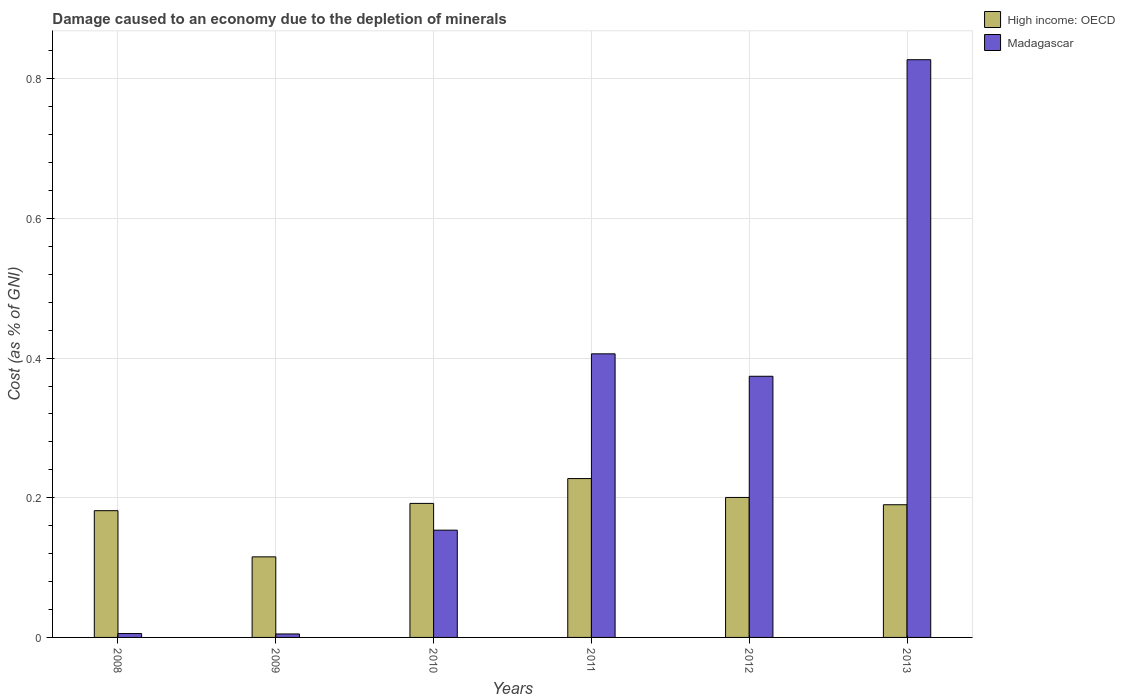How many groups of bars are there?
Your answer should be very brief. 6. Are the number of bars per tick equal to the number of legend labels?
Provide a short and direct response. Yes. How many bars are there on the 1st tick from the left?
Your answer should be compact. 2. How many bars are there on the 1st tick from the right?
Provide a short and direct response. 2. In how many cases, is the number of bars for a given year not equal to the number of legend labels?
Offer a very short reply. 0. What is the cost of damage caused due to the depletion of minerals in High income: OECD in 2011?
Your answer should be compact. 0.23. Across all years, what is the maximum cost of damage caused due to the depletion of minerals in Madagascar?
Make the answer very short. 0.83. Across all years, what is the minimum cost of damage caused due to the depletion of minerals in Madagascar?
Provide a succinct answer. 0. In which year was the cost of damage caused due to the depletion of minerals in High income: OECD minimum?
Your response must be concise. 2009. What is the total cost of damage caused due to the depletion of minerals in High income: OECD in the graph?
Offer a very short reply. 1.11. What is the difference between the cost of damage caused due to the depletion of minerals in High income: OECD in 2009 and that in 2011?
Your response must be concise. -0.11. What is the difference between the cost of damage caused due to the depletion of minerals in Madagascar in 2011 and the cost of damage caused due to the depletion of minerals in High income: OECD in 2009?
Ensure brevity in your answer.  0.29. What is the average cost of damage caused due to the depletion of minerals in High income: OECD per year?
Your answer should be compact. 0.18. In the year 2012, what is the difference between the cost of damage caused due to the depletion of minerals in High income: OECD and cost of damage caused due to the depletion of minerals in Madagascar?
Provide a short and direct response. -0.17. What is the ratio of the cost of damage caused due to the depletion of minerals in Madagascar in 2010 to that in 2011?
Your answer should be very brief. 0.38. Is the cost of damage caused due to the depletion of minerals in High income: OECD in 2009 less than that in 2011?
Offer a terse response. Yes. What is the difference between the highest and the second highest cost of damage caused due to the depletion of minerals in High income: OECD?
Provide a succinct answer. 0.03. What is the difference between the highest and the lowest cost of damage caused due to the depletion of minerals in Madagascar?
Offer a very short reply. 0.82. In how many years, is the cost of damage caused due to the depletion of minerals in Madagascar greater than the average cost of damage caused due to the depletion of minerals in Madagascar taken over all years?
Ensure brevity in your answer.  3. Is the sum of the cost of damage caused due to the depletion of minerals in Madagascar in 2009 and 2013 greater than the maximum cost of damage caused due to the depletion of minerals in High income: OECD across all years?
Make the answer very short. Yes. What does the 2nd bar from the left in 2011 represents?
Keep it short and to the point. Madagascar. What does the 1st bar from the right in 2013 represents?
Provide a succinct answer. Madagascar. How many bars are there?
Your answer should be compact. 12. Are all the bars in the graph horizontal?
Keep it short and to the point. No. How many years are there in the graph?
Offer a very short reply. 6. Are the values on the major ticks of Y-axis written in scientific E-notation?
Make the answer very short. No. Does the graph contain grids?
Provide a short and direct response. Yes. How are the legend labels stacked?
Your answer should be compact. Vertical. What is the title of the graph?
Ensure brevity in your answer.  Damage caused to an economy due to the depletion of minerals. What is the label or title of the X-axis?
Ensure brevity in your answer.  Years. What is the label or title of the Y-axis?
Your answer should be very brief. Cost (as % of GNI). What is the Cost (as % of GNI) in High income: OECD in 2008?
Your response must be concise. 0.18. What is the Cost (as % of GNI) of Madagascar in 2008?
Give a very brief answer. 0.01. What is the Cost (as % of GNI) in High income: OECD in 2009?
Keep it short and to the point. 0.12. What is the Cost (as % of GNI) in Madagascar in 2009?
Give a very brief answer. 0. What is the Cost (as % of GNI) of High income: OECD in 2010?
Provide a short and direct response. 0.19. What is the Cost (as % of GNI) in Madagascar in 2010?
Give a very brief answer. 0.15. What is the Cost (as % of GNI) in High income: OECD in 2011?
Offer a very short reply. 0.23. What is the Cost (as % of GNI) of Madagascar in 2011?
Your answer should be compact. 0.41. What is the Cost (as % of GNI) of High income: OECD in 2012?
Provide a short and direct response. 0.2. What is the Cost (as % of GNI) in Madagascar in 2012?
Offer a very short reply. 0.37. What is the Cost (as % of GNI) in High income: OECD in 2013?
Provide a succinct answer. 0.19. What is the Cost (as % of GNI) in Madagascar in 2013?
Your answer should be compact. 0.83. Across all years, what is the maximum Cost (as % of GNI) of High income: OECD?
Your answer should be compact. 0.23. Across all years, what is the maximum Cost (as % of GNI) of Madagascar?
Your answer should be compact. 0.83. Across all years, what is the minimum Cost (as % of GNI) of High income: OECD?
Keep it short and to the point. 0.12. Across all years, what is the minimum Cost (as % of GNI) in Madagascar?
Provide a succinct answer. 0. What is the total Cost (as % of GNI) in High income: OECD in the graph?
Offer a very short reply. 1.11. What is the total Cost (as % of GNI) in Madagascar in the graph?
Offer a very short reply. 1.77. What is the difference between the Cost (as % of GNI) in High income: OECD in 2008 and that in 2009?
Keep it short and to the point. 0.07. What is the difference between the Cost (as % of GNI) of Madagascar in 2008 and that in 2009?
Your response must be concise. 0. What is the difference between the Cost (as % of GNI) in High income: OECD in 2008 and that in 2010?
Your response must be concise. -0.01. What is the difference between the Cost (as % of GNI) of Madagascar in 2008 and that in 2010?
Your answer should be compact. -0.15. What is the difference between the Cost (as % of GNI) in High income: OECD in 2008 and that in 2011?
Offer a terse response. -0.05. What is the difference between the Cost (as % of GNI) of Madagascar in 2008 and that in 2011?
Offer a terse response. -0.4. What is the difference between the Cost (as % of GNI) of High income: OECD in 2008 and that in 2012?
Make the answer very short. -0.02. What is the difference between the Cost (as % of GNI) of Madagascar in 2008 and that in 2012?
Provide a succinct answer. -0.37. What is the difference between the Cost (as % of GNI) of High income: OECD in 2008 and that in 2013?
Your response must be concise. -0.01. What is the difference between the Cost (as % of GNI) in Madagascar in 2008 and that in 2013?
Provide a succinct answer. -0.82. What is the difference between the Cost (as % of GNI) in High income: OECD in 2009 and that in 2010?
Keep it short and to the point. -0.08. What is the difference between the Cost (as % of GNI) in Madagascar in 2009 and that in 2010?
Your answer should be compact. -0.15. What is the difference between the Cost (as % of GNI) in High income: OECD in 2009 and that in 2011?
Offer a very short reply. -0.11. What is the difference between the Cost (as % of GNI) of Madagascar in 2009 and that in 2011?
Provide a succinct answer. -0.4. What is the difference between the Cost (as % of GNI) in High income: OECD in 2009 and that in 2012?
Offer a terse response. -0.09. What is the difference between the Cost (as % of GNI) of Madagascar in 2009 and that in 2012?
Ensure brevity in your answer.  -0.37. What is the difference between the Cost (as % of GNI) of High income: OECD in 2009 and that in 2013?
Ensure brevity in your answer.  -0.07. What is the difference between the Cost (as % of GNI) in Madagascar in 2009 and that in 2013?
Provide a succinct answer. -0.82. What is the difference between the Cost (as % of GNI) of High income: OECD in 2010 and that in 2011?
Your answer should be compact. -0.04. What is the difference between the Cost (as % of GNI) in Madagascar in 2010 and that in 2011?
Provide a succinct answer. -0.25. What is the difference between the Cost (as % of GNI) of High income: OECD in 2010 and that in 2012?
Provide a succinct answer. -0.01. What is the difference between the Cost (as % of GNI) in Madagascar in 2010 and that in 2012?
Your answer should be very brief. -0.22. What is the difference between the Cost (as % of GNI) of High income: OECD in 2010 and that in 2013?
Provide a succinct answer. 0. What is the difference between the Cost (as % of GNI) of Madagascar in 2010 and that in 2013?
Ensure brevity in your answer.  -0.67. What is the difference between the Cost (as % of GNI) in High income: OECD in 2011 and that in 2012?
Give a very brief answer. 0.03. What is the difference between the Cost (as % of GNI) in Madagascar in 2011 and that in 2012?
Keep it short and to the point. 0.03. What is the difference between the Cost (as % of GNI) of High income: OECD in 2011 and that in 2013?
Provide a succinct answer. 0.04. What is the difference between the Cost (as % of GNI) in Madagascar in 2011 and that in 2013?
Your answer should be compact. -0.42. What is the difference between the Cost (as % of GNI) of High income: OECD in 2012 and that in 2013?
Ensure brevity in your answer.  0.01. What is the difference between the Cost (as % of GNI) of Madagascar in 2012 and that in 2013?
Offer a terse response. -0.45. What is the difference between the Cost (as % of GNI) in High income: OECD in 2008 and the Cost (as % of GNI) in Madagascar in 2009?
Your response must be concise. 0.18. What is the difference between the Cost (as % of GNI) of High income: OECD in 2008 and the Cost (as % of GNI) of Madagascar in 2010?
Provide a succinct answer. 0.03. What is the difference between the Cost (as % of GNI) in High income: OECD in 2008 and the Cost (as % of GNI) in Madagascar in 2011?
Your answer should be compact. -0.22. What is the difference between the Cost (as % of GNI) in High income: OECD in 2008 and the Cost (as % of GNI) in Madagascar in 2012?
Give a very brief answer. -0.19. What is the difference between the Cost (as % of GNI) of High income: OECD in 2008 and the Cost (as % of GNI) of Madagascar in 2013?
Make the answer very short. -0.65. What is the difference between the Cost (as % of GNI) in High income: OECD in 2009 and the Cost (as % of GNI) in Madagascar in 2010?
Your answer should be very brief. -0.04. What is the difference between the Cost (as % of GNI) in High income: OECD in 2009 and the Cost (as % of GNI) in Madagascar in 2011?
Offer a very short reply. -0.29. What is the difference between the Cost (as % of GNI) in High income: OECD in 2009 and the Cost (as % of GNI) in Madagascar in 2012?
Provide a succinct answer. -0.26. What is the difference between the Cost (as % of GNI) in High income: OECD in 2009 and the Cost (as % of GNI) in Madagascar in 2013?
Ensure brevity in your answer.  -0.71. What is the difference between the Cost (as % of GNI) of High income: OECD in 2010 and the Cost (as % of GNI) of Madagascar in 2011?
Keep it short and to the point. -0.21. What is the difference between the Cost (as % of GNI) of High income: OECD in 2010 and the Cost (as % of GNI) of Madagascar in 2012?
Offer a terse response. -0.18. What is the difference between the Cost (as % of GNI) of High income: OECD in 2010 and the Cost (as % of GNI) of Madagascar in 2013?
Your answer should be compact. -0.64. What is the difference between the Cost (as % of GNI) of High income: OECD in 2011 and the Cost (as % of GNI) of Madagascar in 2012?
Your answer should be very brief. -0.15. What is the difference between the Cost (as % of GNI) of High income: OECD in 2011 and the Cost (as % of GNI) of Madagascar in 2013?
Provide a succinct answer. -0.6. What is the difference between the Cost (as % of GNI) of High income: OECD in 2012 and the Cost (as % of GNI) of Madagascar in 2013?
Ensure brevity in your answer.  -0.63. What is the average Cost (as % of GNI) of High income: OECD per year?
Your response must be concise. 0.18. What is the average Cost (as % of GNI) in Madagascar per year?
Ensure brevity in your answer.  0.3. In the year 2008, what is the difference between the Cost (as % of GNI) in High income: OECD and Cost (as % of GNI) in Madagascar?
Your answer should be compact. 0.18. In the year 2009, what is the difference between the Cost (as % of GNI) of High income: OECD and Cost (as % of GNI) of Madagascar?
Make the answer very short. 0.11. In the year 2010, what is the difference between the Cost (as % of GNI) in High income: OECD and Cost (as % of GNI) in Madagascar?
Your answer should be compact. 0.04. In the year 2011, what is the difference between the Cost (as % of GNI) of High income: OECD and Cost (as % of GNI) of Madagascar?
Provide a succinct answer. -0.18. In the year 2012, what is the difference between the Cost (as % of GNI) of High income: OECD and Cost (as % of GNI) of Madagascar?
Provide a succinct answer. -0.17. In the year 2013, what is the difference between the Cost (as % of GNI) in High income: OECD and Cost (as % of GNI) in Madagascar?
Your answer should be very brief. -0.64. What is the ratio of the Cost (as % of GNI) of High income: OECD in 2008 to that in 2009?
Keep it short and to the point. 1.57. What is the ratio of the Cost (as % of GNI) in Madagascar in 2008 to that in 2009?
Provide a succinct answer. 1.12. What is the ratio of the Cost (as % of GNI) in High income: OECD in 2008 to that in 2010?
Provide a short and direct response. 0.95. What is the ratio of the Cost (as % of GNI) in Madagascar in 2008 to that in 2010?
Give a very brief answer. 0.04. What is the ratio of the Cost (as % of GNI) of High income: OECD in 2008 to that in 2011?
Your answer should be very brief. 0.8. What is the ratio of the Cost (as % of GNI) of Madagascar in 2008 to that in 2011?
Your answer should be compact. 0.01. What is the ratio of the Cost (as % of GNI) of High income: OECD in 2008 to that in 2012?
Keep it short and to the point. 0.91. What is the ratio of the Cost (as % of GNI) in Madagascar in 2008 to that in 2012?
Provide a succinct answer. 0.01. What is the ratio of the Cost (as % of GNI) in High income: OECD in 2008 to that in 2013?
Make the answer very short. 0.96. What is the ratio of the Cost (as % of GNI) of Madagascar in 2008 to that in 2013?
Offer a very short reply. 0.01. What is the ratio of the Cost (as % of GNI) of High income: OECD in 2009 to that in 2010?
Keep it short and to the point. 0.6. What is the ratio of the Cost (as % of GNI) of Madagascar in 2009 to that in 2010?
Provide a succinct answer. 0.03. What is the ratio of the Cost (as % of GNI) in High income: OECD in 2009 to that in 2011?
Your answer should be very brief. 0.51. What is the ratio of the Cost (as % of GNI) in Madagascar in 2009 to that in 2011?
Your answer should be very brief. 0.01. What is the ratio of the Cost (as % of GNI) in High income: OECD in 2009 to that in 2012?
Offer a terse response. 0.58. What is the ratio of the Cost (as % of GNI) of Madagascar in 2009 to that in 2012?
Offer a terse response. 0.01. What is the ratio of the Cost (as % of GNI) in High income: OECD in 2009 to that in 2013?
Your response must be concise. 0.61. What is the ratio of the Cost (as % of GNI) of Madagascar in 2009 to that in 2013?
Offer a very short reply. 0.01. What is the ratio of the Cost (as % of GNI) in High income: OECD in 2010 to that in 2011?
Offer a very short reply. 0.84. What is the ratio of the Cost (as % of GNI) in Madagascar in 2010 to that in 2011?
Your response must be concise. 0.38. What is the ratio of the Cost (as % of GNI) of High income: OECD in 2010 to that in 2012?
Offer a very short reply. 0.96. What is the ratio of the Cost (as % of GNI) of Madagascar in 2010 to that in 2012?
Keep it short and to the point. 0.41. What is the ratio of the Cost (as % of GNI) in Madagascar in 2010 to that in 2013?
Your answer should be compact. 0.19. What is the ratio of the Cost (as % of GNI) of High income: OECD in 2011 to that in 2012?
Provide a short and direct response. 1.13. What is the ratio of the Cost (as % of GNI) of Madagascar in 2011 to that in 2012?
Provide a succinct answer. 1.09. What is the ratio of the Cost (as % of GNI) in High income: OECD in 2011 to that in 2013?
Make the answer very short. 1.2. What is the ratio of the Cost (as % of GNI) in Madagascar in 2011 to that in 2013?
Your answer should be very brief. 0.49. What is the ratio of the Cost (as % of GNI) of High income: OECD in 2012 to that in 2013?
Make the answer very short. 1.05. What is the ratio of the Cost (as % of GNI) in Madagascar in 2012 to that in 2013?
Your answer should be compact. 0.45. What is the difference between the highest and the second highest Cost (as % of GNI) in High income: OECD?
Your answer should be very brief. 0.03. What is the difference between the highest and the second highest Cost (as % of GNI) in Madagascar?
Offer a terse response. 0.42. What is the difference between the highest and the lowest Cost (as % of GNI) of High income: OECD?
Your answer should be very brief. 0.11. What is the difference between the highest and the lowest Cost (as % of GNI) in Madagascar?
Provide a short and direct response. 0.82. 